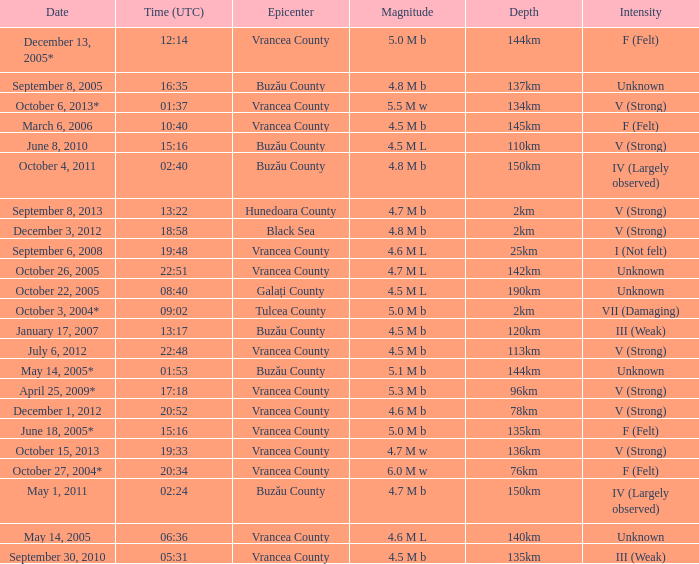What is the depth of the quake that occurred at 19:48? 25km. 